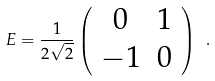<formula> <loc_0><loc_0><loc_500><loc_500>E = \frac { 1 } { 2 \sqrt { 2 } } \left ( \begin{array} { c c } { 0 } & { 1 } \\ - { 1 } & { 0 } \end{array} \right ) \ .</formula> 